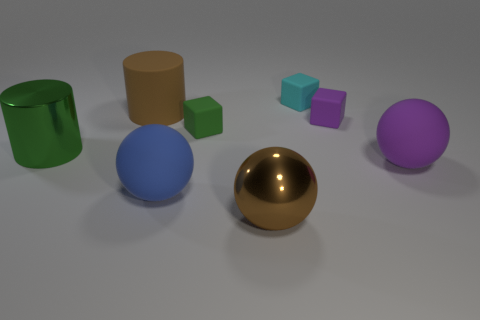Subtract all big rubber spheres. How many spheres are left? 1 Add 1 matte objects. How many objects exist? 9 Subtract all blue spheres. How many spheres are left? 2 Subtract all balls. How many objects are left? 5 Subtract all brown cubes. Subtract all yellow cylinders. How many cubes are left? 3 Subtract all red cylinders. How many cyan cubes are left? 1 Subtract all big cylinders. Subtract all purple cubes. How many objects are left? 5 Add 3 shiny things. How many shiny things are left? 5 Add 5 small green things. How many small green things exist? 6 Subtract 0 blue cylinders. How many objects are left? 8 